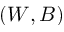<formula> <loc_0><loc_0><loc_500><loc_500>( W , B )</formula> 